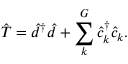Convert formula to latex. <formula><loc_0><loc_0><loc_500><loc_500>\hat { T } = \hat { d } ^ { \dagger } \hat { d } + \sum _ { k } ^ { G } \hat { c } _ { k } ^ { \dagger } \hat { c } _ { k } .</formula> 